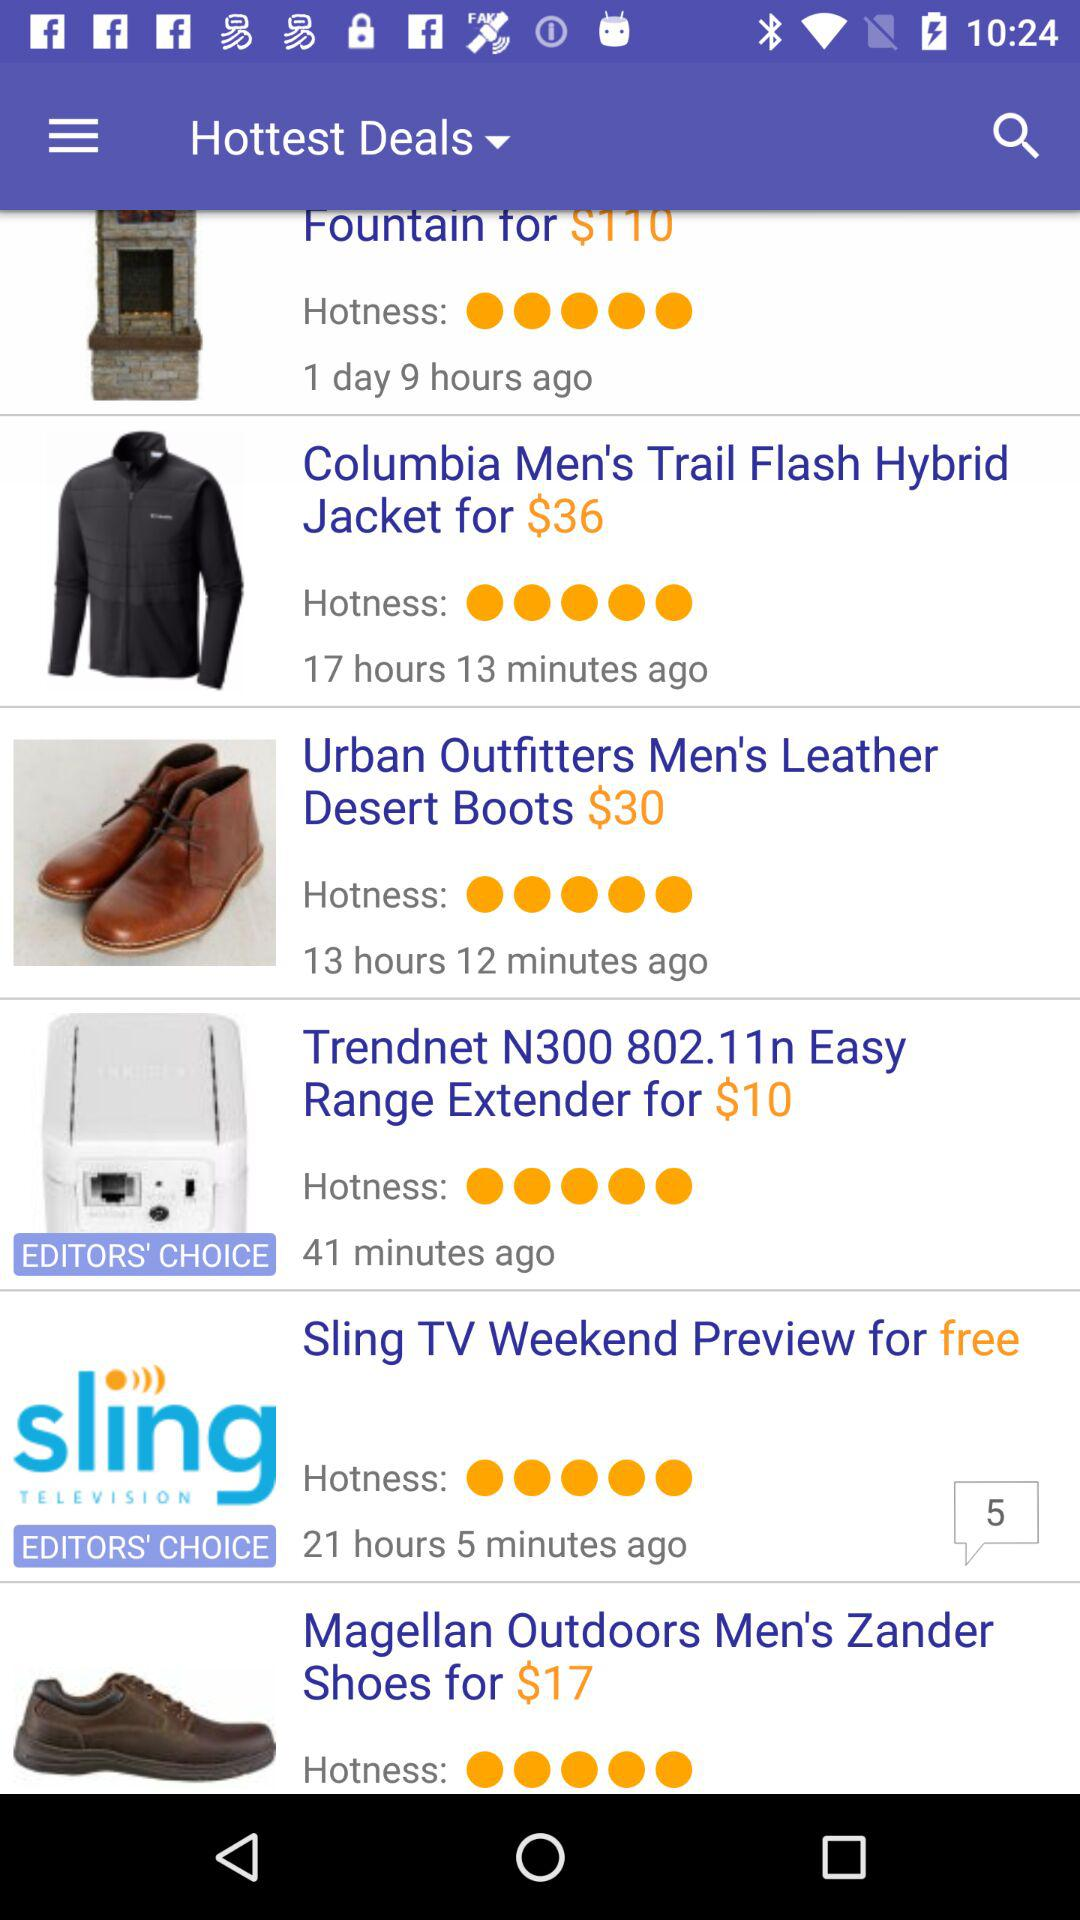What is the price of the "Trendnet N300 802.11n Easy Range Extender"? The price is $10. 